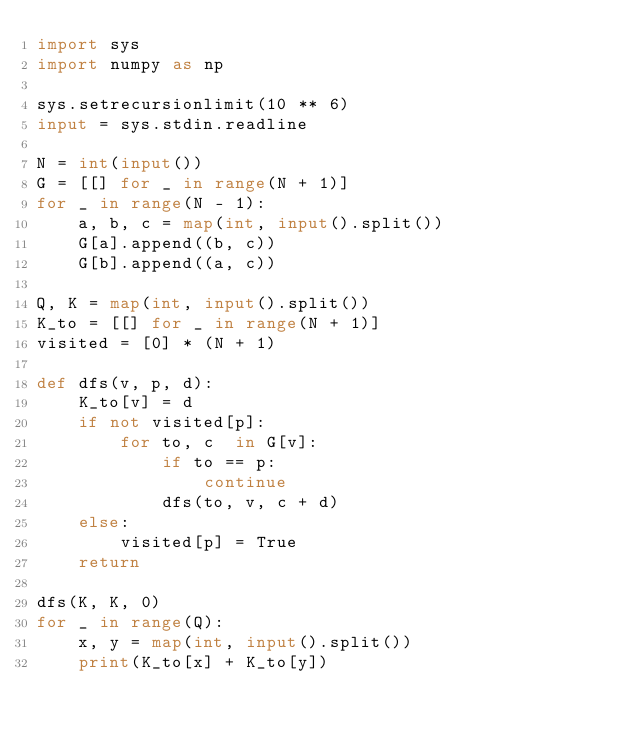Convert code to text. <code><loc_0><loc_0><loc_500><loc_500><_Python_>import sys
import numpy as np

sys.setrecursionlimit(10 ** 6)
input = sys.stdin.readline

N = int(input())
G = [[] for _ in range(N + 1)]
for _ in range(N - 1):
    a, b, c = map(int, input().split())
    G[a].append((b, c))
    G[b].append((a, c))

Q, K = map(int, input().split())
K_to = [[] for _ in range(N + 1)]
visited = [0] * (N + 1)

def dfs(v, p, d):
    K_to[v] = d
    if not visited[p]:
        for to, c  in G[v]:
            if to == p:
                continue
            dfs(to, v, c + d)
    else:
        visited[p] = True
    return

dfs(K, K, 0)
for _ in range(Q):
    x, y = map(int, input().split())
    print(K_to[x] + K_to[y])</code> 